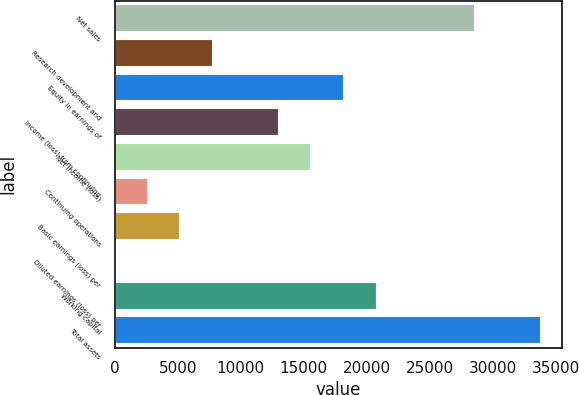Convert chart to OTSL. <chart><loc_0><loc_0><loc_500><loc_500><bar_chart><fcel>Net sales<fcel>Research development and<fcel>Equity in earnings of<fcel>Income (loss) from continuing<fcel>Net income (loss)<fcel>Continuing operations<fcel>Basic earnings (loss) per<fcel>Diluted earnings (loss) per<fcel>Working capital<fcel>Total assets<nl><fcel>28599.9<fcel>7800.26<fcel>18200.1<fcel>13000.2<fcel>15600.1<fcel>2600.34<fcel>5200.3<fcel>0.38<fcel>20800.1<fcel>33799.9<nl></chart> 